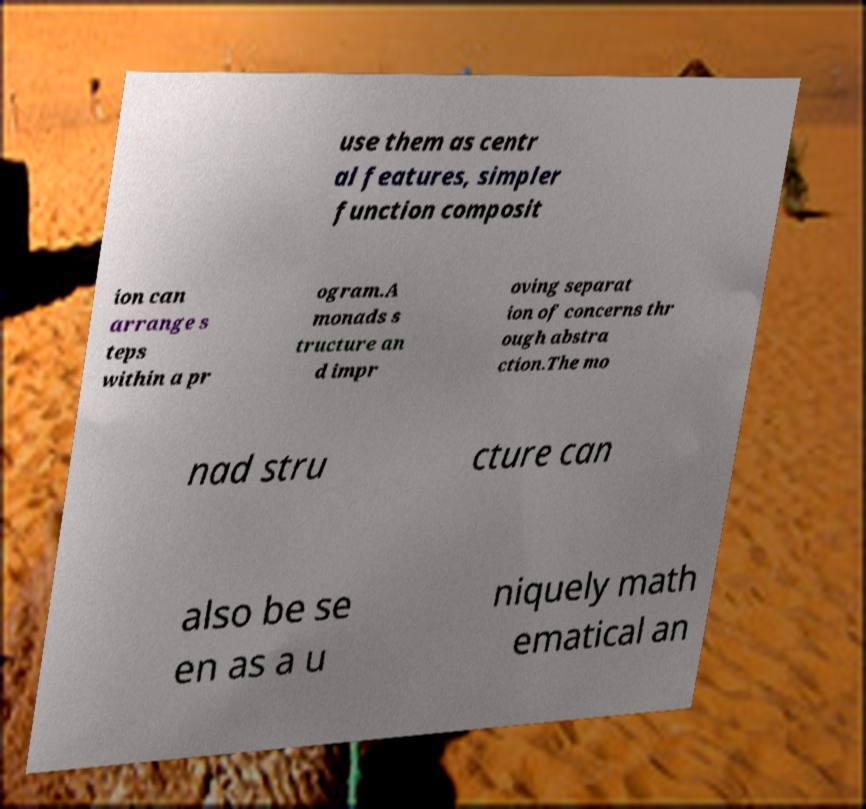Could you extract and type out the text from this image? use them as centr al features, simpler function composit ion can arrange s teps within a pr ogram.A monads s tructure an d impr oving separat ion of concerns thr ough abstra ction.The mo nad stru cture can also be se en as a u niquely math ematical an 